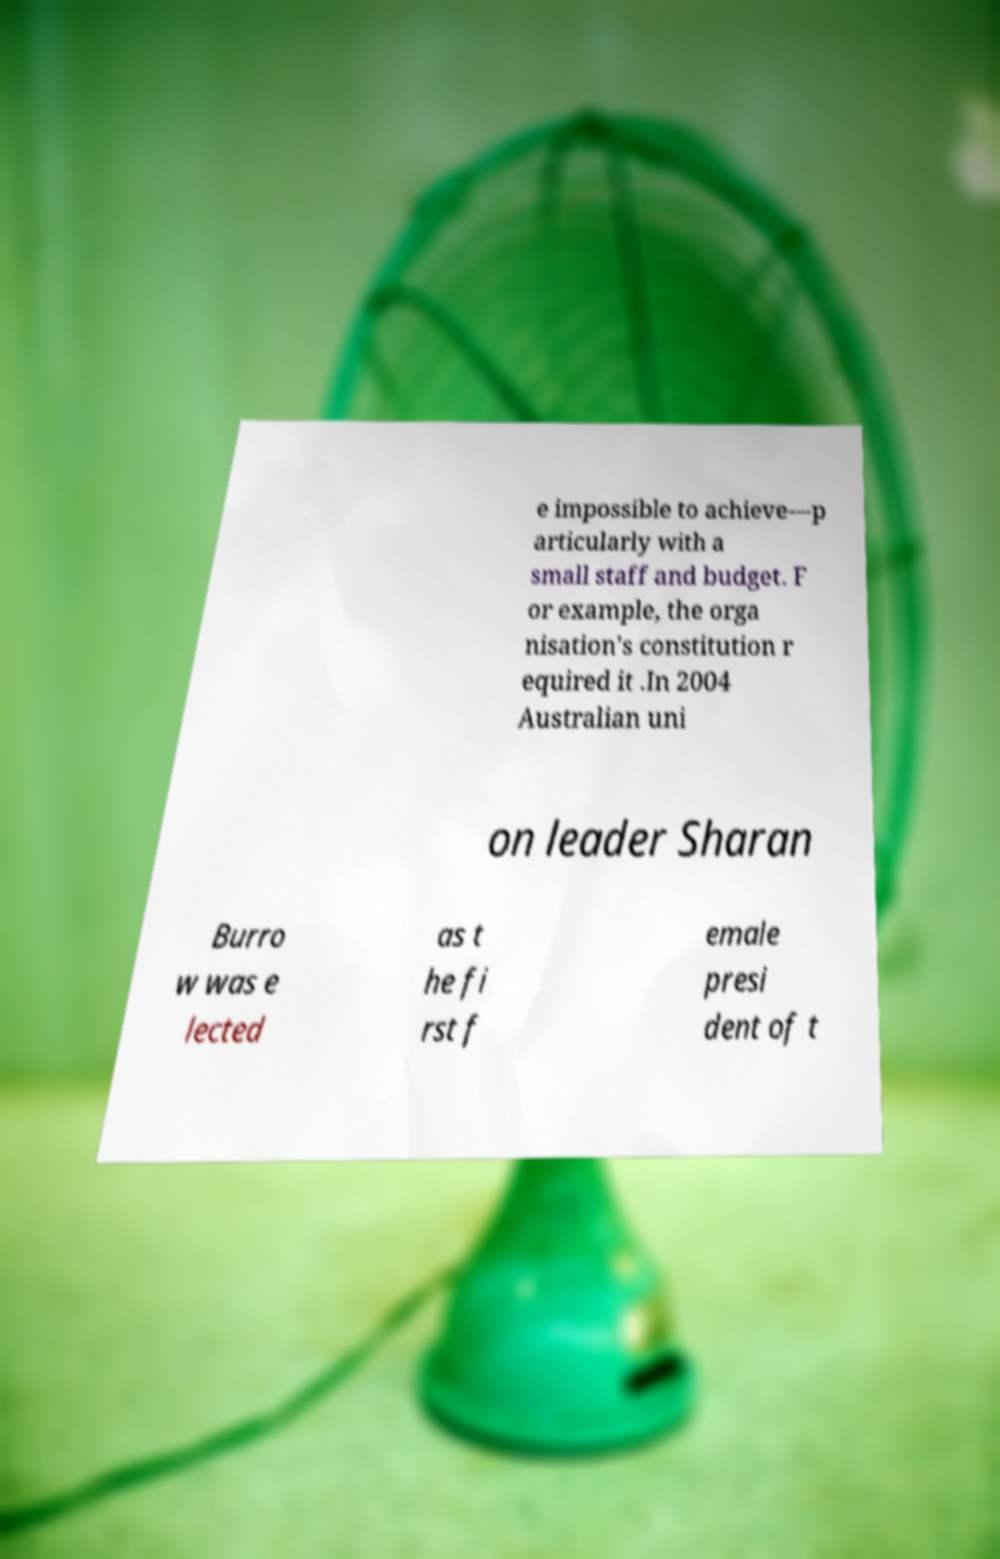Can you accurately transcribe the text from the provided image for me? e impossible to achieve—p articularly with a small staff and budget. F or example, the orga nisation's constitution r equired it .In 2004 Australian uni on leader Sharan Burro w was e lected as t he fi rst f emale presi dent of t 